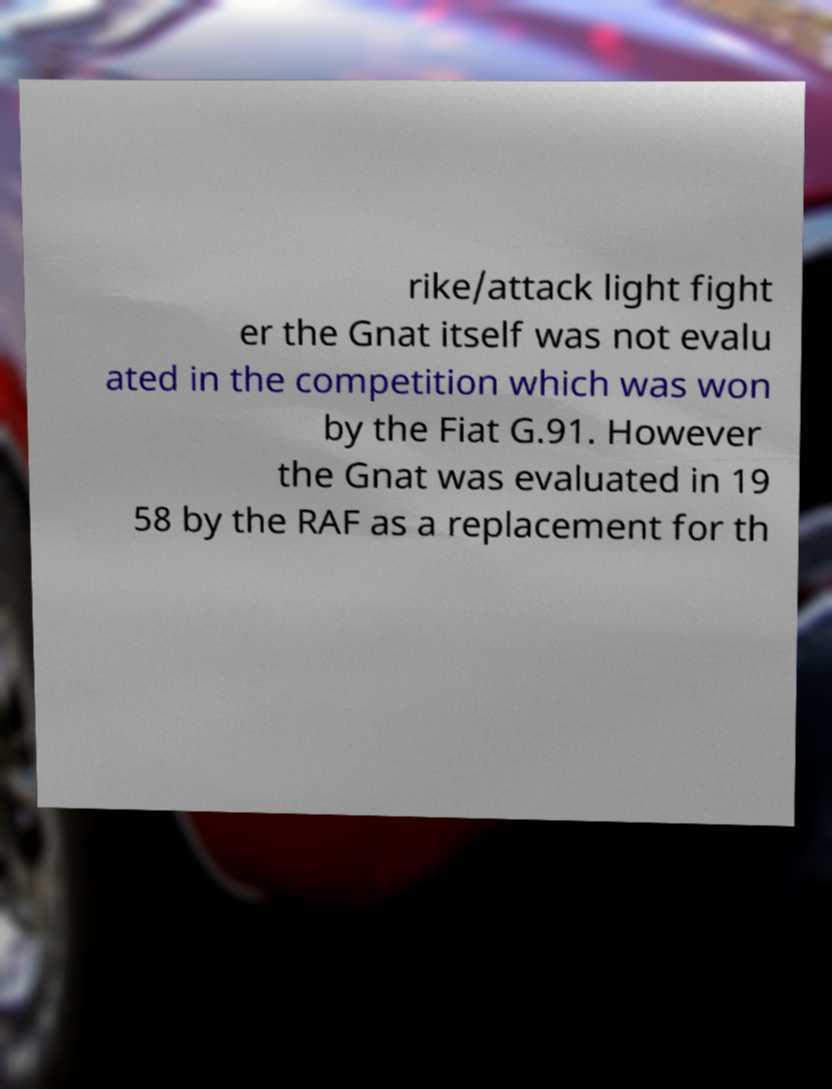I need the written content from this picture converted into text. Can you do that? rike/attack light fight er the Gnat itself was not evalu ated in the competition which was won by the Fiat G.91. However the Gnat was evaluated in 19 58 by the RAF as a replacement for th 